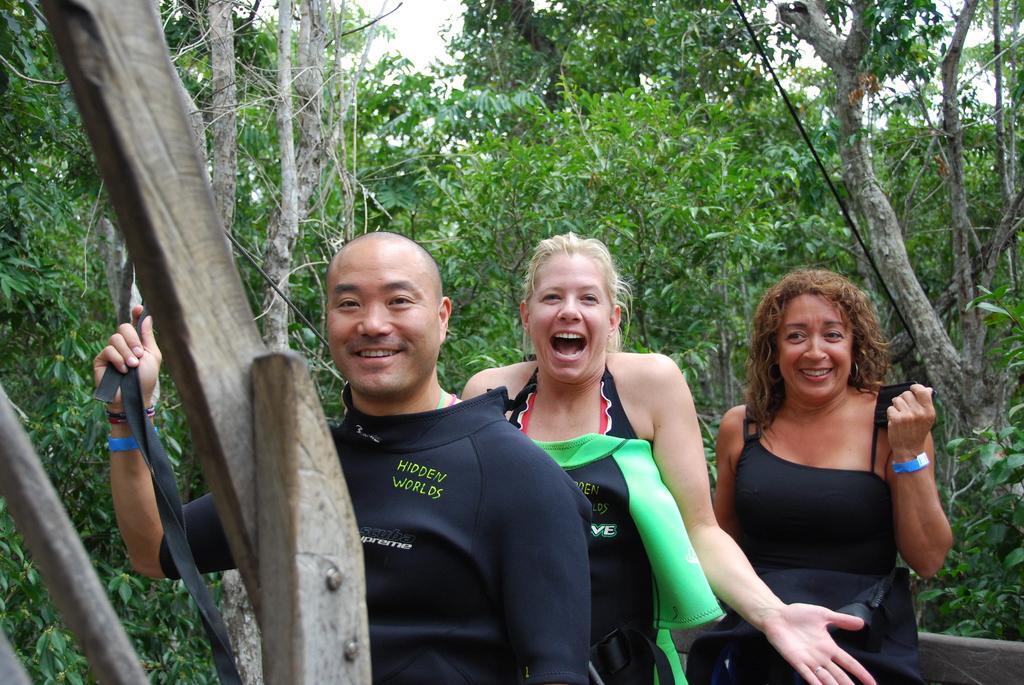Could you give a brief overview of what you see in this image? In this image I can see three persons are standing and I can see all of them are wearing black colour of dress. I can also see smile on their faces and on the left side I can see one person is holding a black belt. In the background I can see number of trees, the sky, two wires and on the left side I can see few wooden things. 